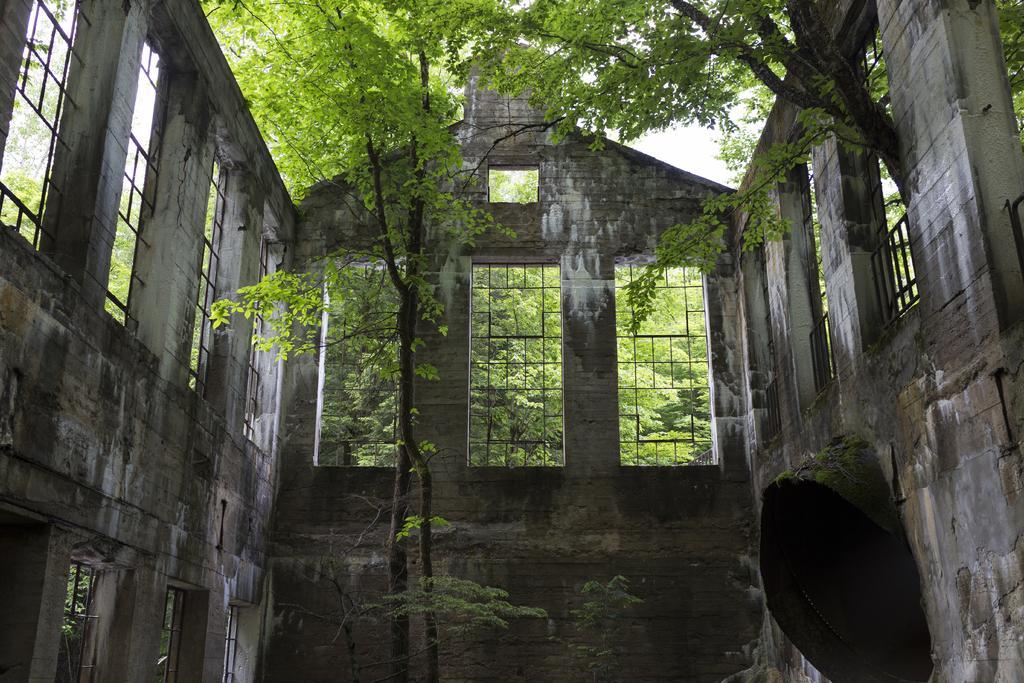Can you describe this image briefly? In this image there is a tree surrounded by the wall having windows. Background there are trees. Behind there is sky. 